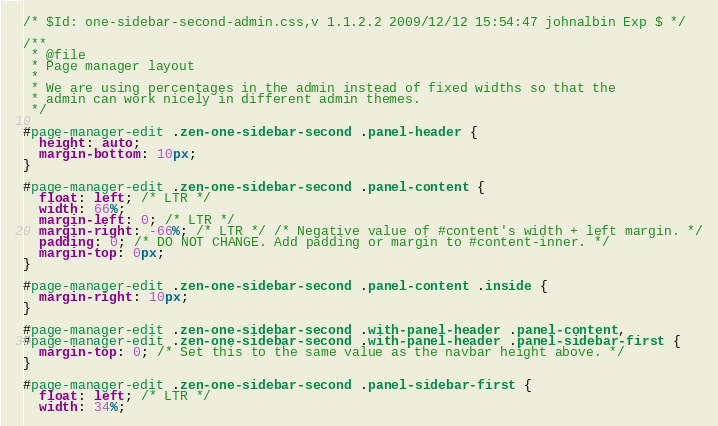<code> <loc_0><loc_0><loc_500><loc_500><_CSS_>/* $Id: one-sidebar-second-admin.css,v 1.1.2.2 2009/12/12 15:54:47 johnalbin Exp $ */

/**
 * @file
 * Page manager layout
 *
 * We are using percentages in the admin instead of fixed widths so that the
 * admin can work nicely in different admin themes.
 */

#page-manager-edit .zen-one-sidebar-second .panel-header {
  height: auto;
  margin-bottom: 10px;
}

#page-manager-edit .zen-one-sidebar-second .panel-content {
  float: left; /* LTR */
  width: 66%;
  margin-left: 0; /* LTR */
  margin-right: -66%; /* LTR */ /* Negative value of #content's width + left margin. */
  padding: 0; /* DO NOT CHANGE. Add padding or margin to #content-inner. */
  margin-top: 0px;
}

#page-manager-edit .zen-one-sidebar-second .panel-content .inside {
  margin-right: 10px;
}

#page-manager-edit .zen-one-sidebar-second .with-panel-header .panel-content,
#page-manager-edit .zen-one-sidebar-second .with-panel-header .panel-sidebar-first {
  margin-top: 0; /* Set this to the same value as the navbar height above. */
}

#page-manager-edit .zen-one-sidebar-second .panel-sidebar-first {
  float: left; /* LTR */
  width: 34%;</code> 